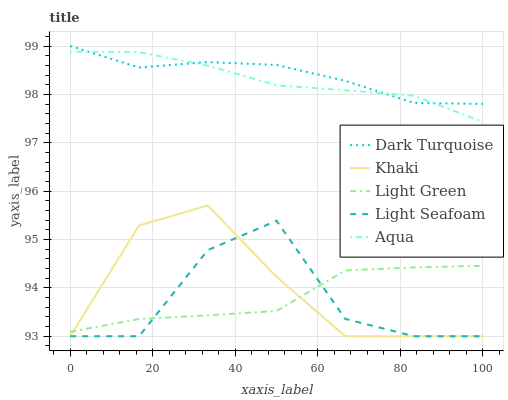Does Light Seafoam have the minimum area under the curve?
Answer yes or no. Yes. Does Dark Turquoise have the maximum area under the curve?
Answer yes or no. Yes. Does Khaki have the minimum area under the curve?
Answer yes or no. No. Does Khaki have the maximum area under the curve?
Answer yes or no. No. Is Aqua the smoothest?
Answer yes or no. Yes. Is Light Seafoam the roughest?
Answer yes or no. Yes. Is Dark Turquoise the smoothest?
Answer yes or no. No. Is Dark Turquoise the roughest?
Answer yes or no. No. Does Dark Turquoise have the lowest value?
Answer yes or no. No. Does Dark Turquoise have the highest value?
Answer yes or no. Yes. Does Khaki have the highest value?
Answer yes or no. No. Is Light Green less than Dark Turquoise?
Answer yes or no. Yes. Is Dark Turquoise greater than Light Seafoam?
Answer yes or no. Yes. Does Light Seafoam intersect Khaki?
Answer yes or no. Yes. Is Light Seafoam less than Khaki?
Answer yes or no. No. Is Light Seafoam greater than Khaki?
Answer yes or no. No. Does Light Green intersect Dark Turquoise?
Answer yes or no. No. 